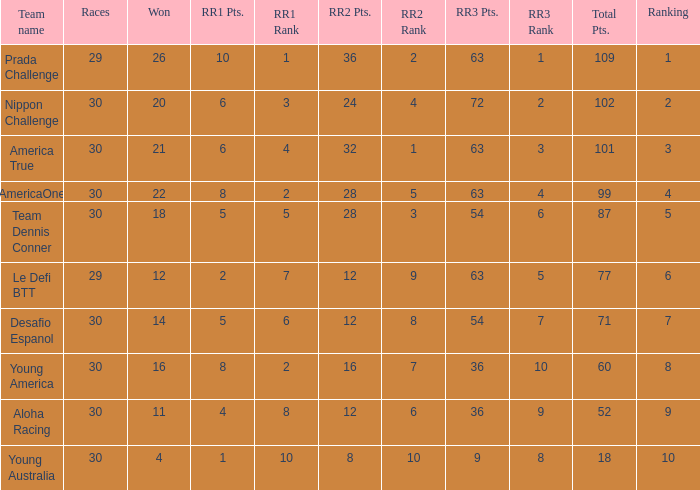Name the ranking for rr2 pts being 8 10.0. 